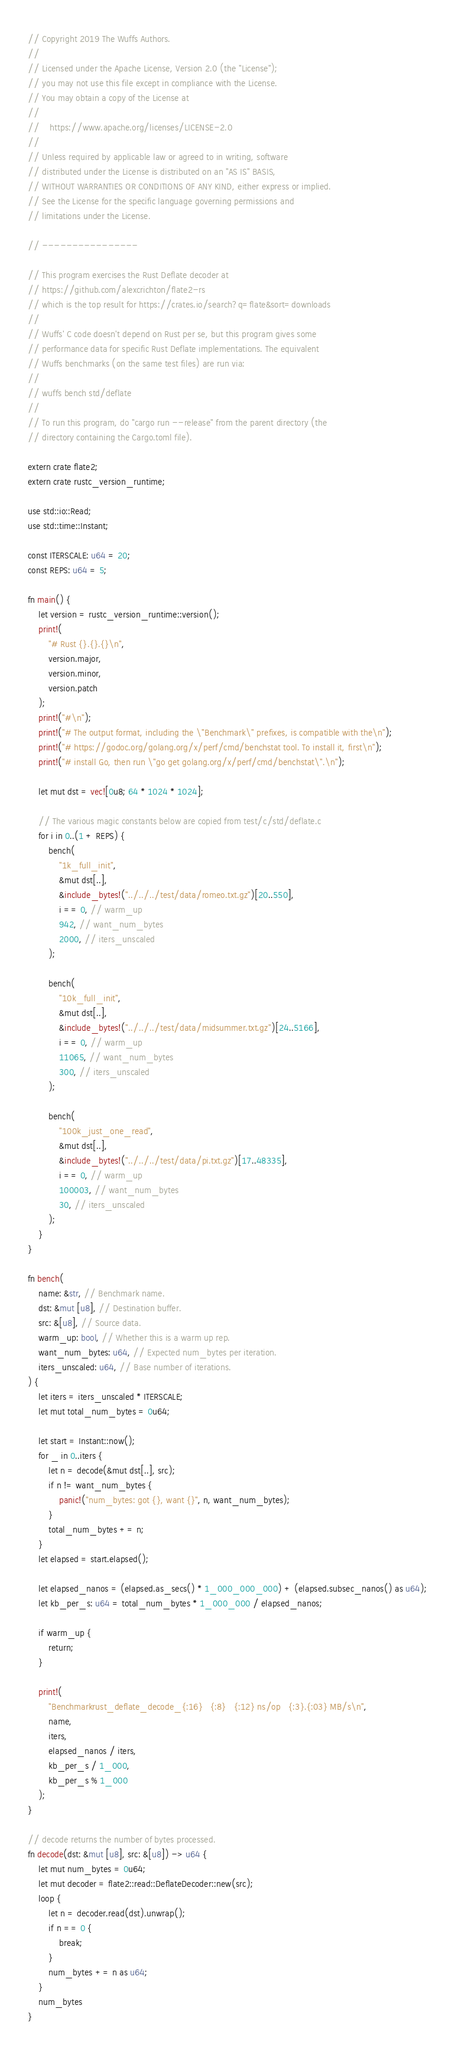<code> <loc_0><loc_0><loc_500><loc_500><_Rust_>// Copyright 2019 The Wuffs Authors.
//
// Licensed under the Apache License, Version 2.0 (the "License");
// you may not use this file except in compliance with the License.
// You may obtain a copy of the License at
//
//    https://www.apache.org/licenses/LICENSE-2.0
//
// Unless required by applicable law or agreed to in writing, software
// distributed under the License is distributed on an "AS IS" BASIS,
// WITHOUT WARRANTIES OR CONDITIONS OF ANY KIND, either express or implied.
// See the License for the specific language governing permissions and
// limitations under the License.

// ----------------

// This program exercises the Rust Deflate decoder at
// https://github.com/alexcrichton/flate2-rs
// which is the top result for https://crates.io/search?q=flate&sort=downloads
//
// Wuffs' C code doesn't depend on Rust per se, but this program gives some
// performance data for specific Rust Deflate implementations. The equivalent
// Wuffs benchmarks (on the same test files) are run via:
//
// wuffs bench std/deflate
//
// To run this program, do "cargo run --release" from the parent directory (the
// directory containing the Cargo.toml file).

extern crate flate2;
extern crate rustc_version_runtime;

use std::io::Read;
use std::time::Instant;

const ITERSCALE: u64 = 20;
const REPS: u64 = 5;

fn main() {
    let version = rustc_version_runtime::version();
    print!(
        "# Rust {}.{}.{}\n",
        version.major,
        version.minor,
        version.patch
    );
    print!("#\n");
    print!("# The output format, including the \"Benchmark\" prefixes, is compatible with the\n");
    print!("# https://godoc.org/golang.org/x/perf/cmd/benchstat tool. To install it, first\n");
    print!("# install Go, then run \"go get golang.org/x/perf/cmd/benchstat\".\n");

    let mut dst = vec![0u8; 64 * 1024 * 1024];

    // The various magic constants below are copied from test/c/std/deflate.c
    for i in 0..(1 + REPS) {
        bench(
            "1k_full_init",
            &mut dst[..],
            &include_bytes!("../../../test/data/romeo.txt.gz")[20..550],
            i == 0, // warm_up
            942, // want_num_bytes
            2000, // iters_unscaled
        );

        bench(
            "10k_full_init",
            &mut dst[..],
            &include_bytes!("../../../test/data/midsummer.txt.gz")[24..5166],
            i == 0, // warm_up
            11065, // want_num_bytes
            300, // iters_unscaled
        );

        bench(
            "100k_just_one_read",
            &mut dst[..],
            &include_bytes!("../../../test/data/pi.txt.gz")[17..48335],
            i == 0, // warm_up
            100003, // want_num_bytes
            30, // iters_unscaled
        );
    }
}

fn bench(
    name: &str, // Benchmark name.
    dst: &mut [u8], // Destination buffer.
    src: &[u8], // Source data.
    warm_up: bool, // Whether this is a warm up rep.
    want_num_bytes: u64, // Expected num_bytes per iteration.
    iters_unscaled: u64, // Base number of iterations.
) {
    let iters = iters_unscaled * ITERSCALE;
    let mut total_num_bytes = 0u64;

    let start = Instant::now();
    for _ in 0..iters {
        let n = decode(&mut dst[..], src);
        if n != want_num_bytes {
            panic!("num_bytes: got {}, want {}", n, want_num_bytes);
        }
        total_num_bytes += n;
    }
    let elapsed = start.elapsed();

    let elapsed_nanos = (elapsed.as_secs() * 1_000_000_000) + (elapsed.subsec_nanos() as u64);
    let kb_per_s: u64 = total_num_bytes * 1_000_000 / elapsed_nanos;

    if warm_up {
        return;
    }

    print!(
        "Benchmarkrust_deflate_decode_{:16}   {:8}   {:12} ns/op   {:3}.{:03} MB/s\n",
        name,
        iters,
        elapsed_nanos / iters,
        kb_per_s / 1_000,
        kb_per_s % 1_000
    );
}

// decode returns the number of bytes processed.
fn decode(dst: &mut [u8], src: &[u8]) -> u64 {
    let mut num_bytes = 0u64;
    let mut decoder = flate2::read::DeflateDecoder::new(src);
    loop {
        let n = decoder.read(dst).unwrap();
        if n == 0 {
            break;
        }
        num_bytes += n as u64;
    }
    num_bytes
}
</code> 